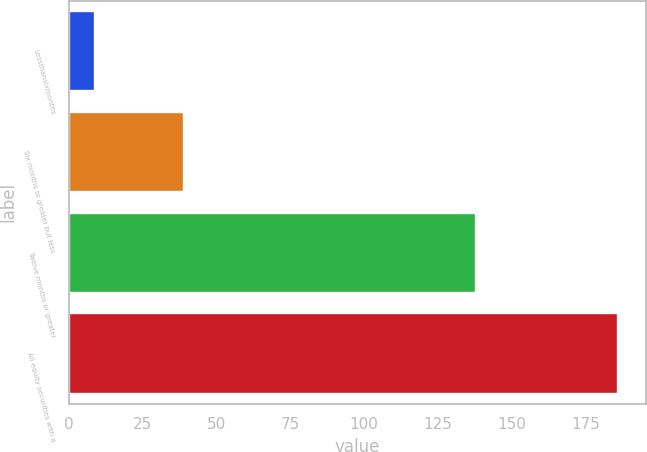Convert chart. <chart><loc_0><loc_0><loc_500><loc_500><bar_chart><fcel>Lessthansixmonths<fcel>Six months or greater but less<fcel>Twelve months or greater<fcel>All equity securities with a<nl><fcel>9<fcel>39<fcel>138<fcel>186<nl></chart> 